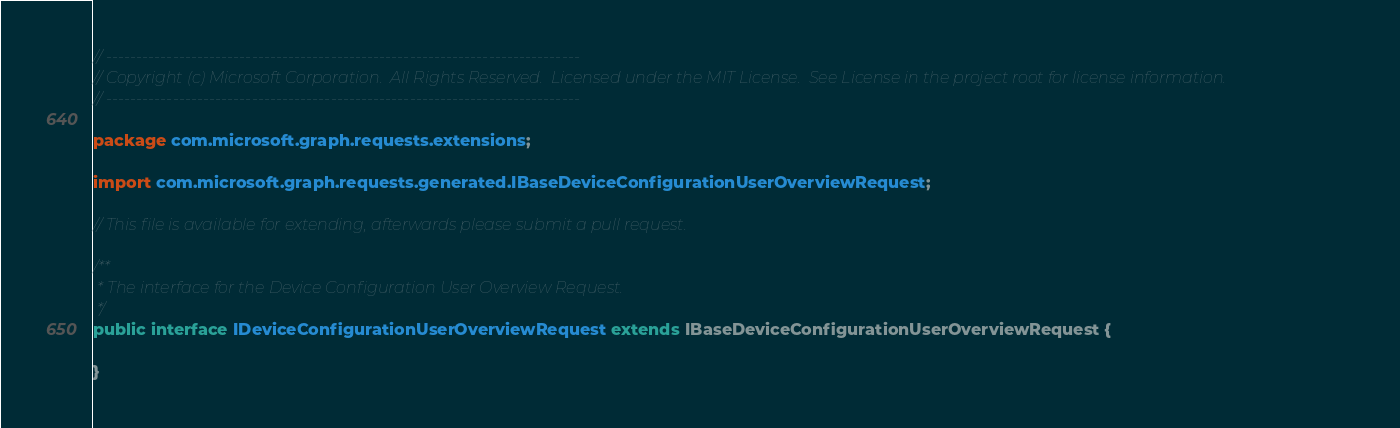<code> <loc_0><loc_0><loc_500><loc_500><_Java_>// ------------------------------------------------------------------------------
// Copyright (c) Microsoft Corporation.  All Rights Reserved.  Licensed under the MIT License.  See License in the project root for license information.
// ------------------------------------------------------------------------------

package com.microsoft.graph.requests.extensions;

import com.microsoft.graph.requests.generated.IBaseDeviceConfigurationUserOverviewRequest;

// This file is available for extending, afterwards please submit a pull request.

/**
 * The interface for the Device Configuration User Overview Request.
 */
public interface IDeviceConfigurationUserOverviewRequest extends IBaseDeviceConfigurationUserOverviewRequest {

}
</code> 